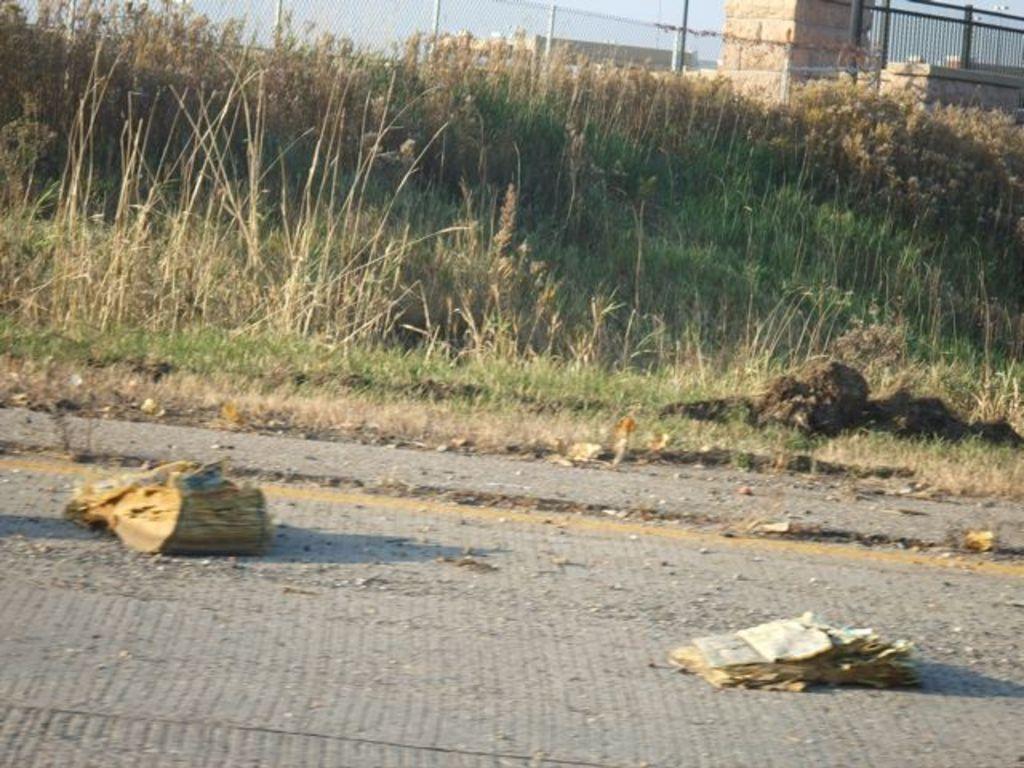Could you give a brief overview of what you see in this image? In this picture I can see grass and I can see buildings and I can see a metal fence and few papers on the road. 